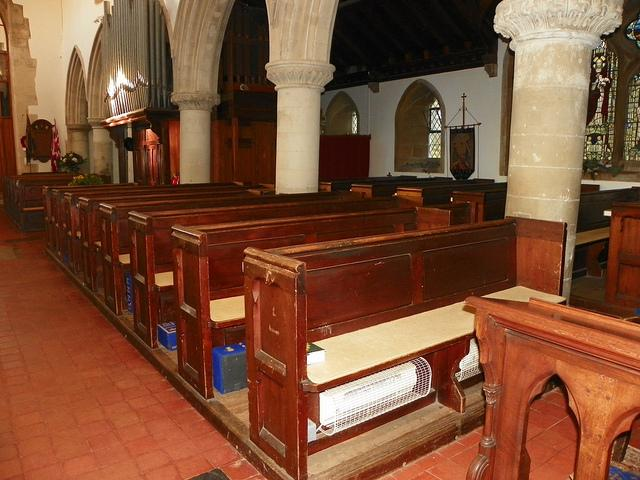What are the objects which are placed underneath the church pews? heaters 